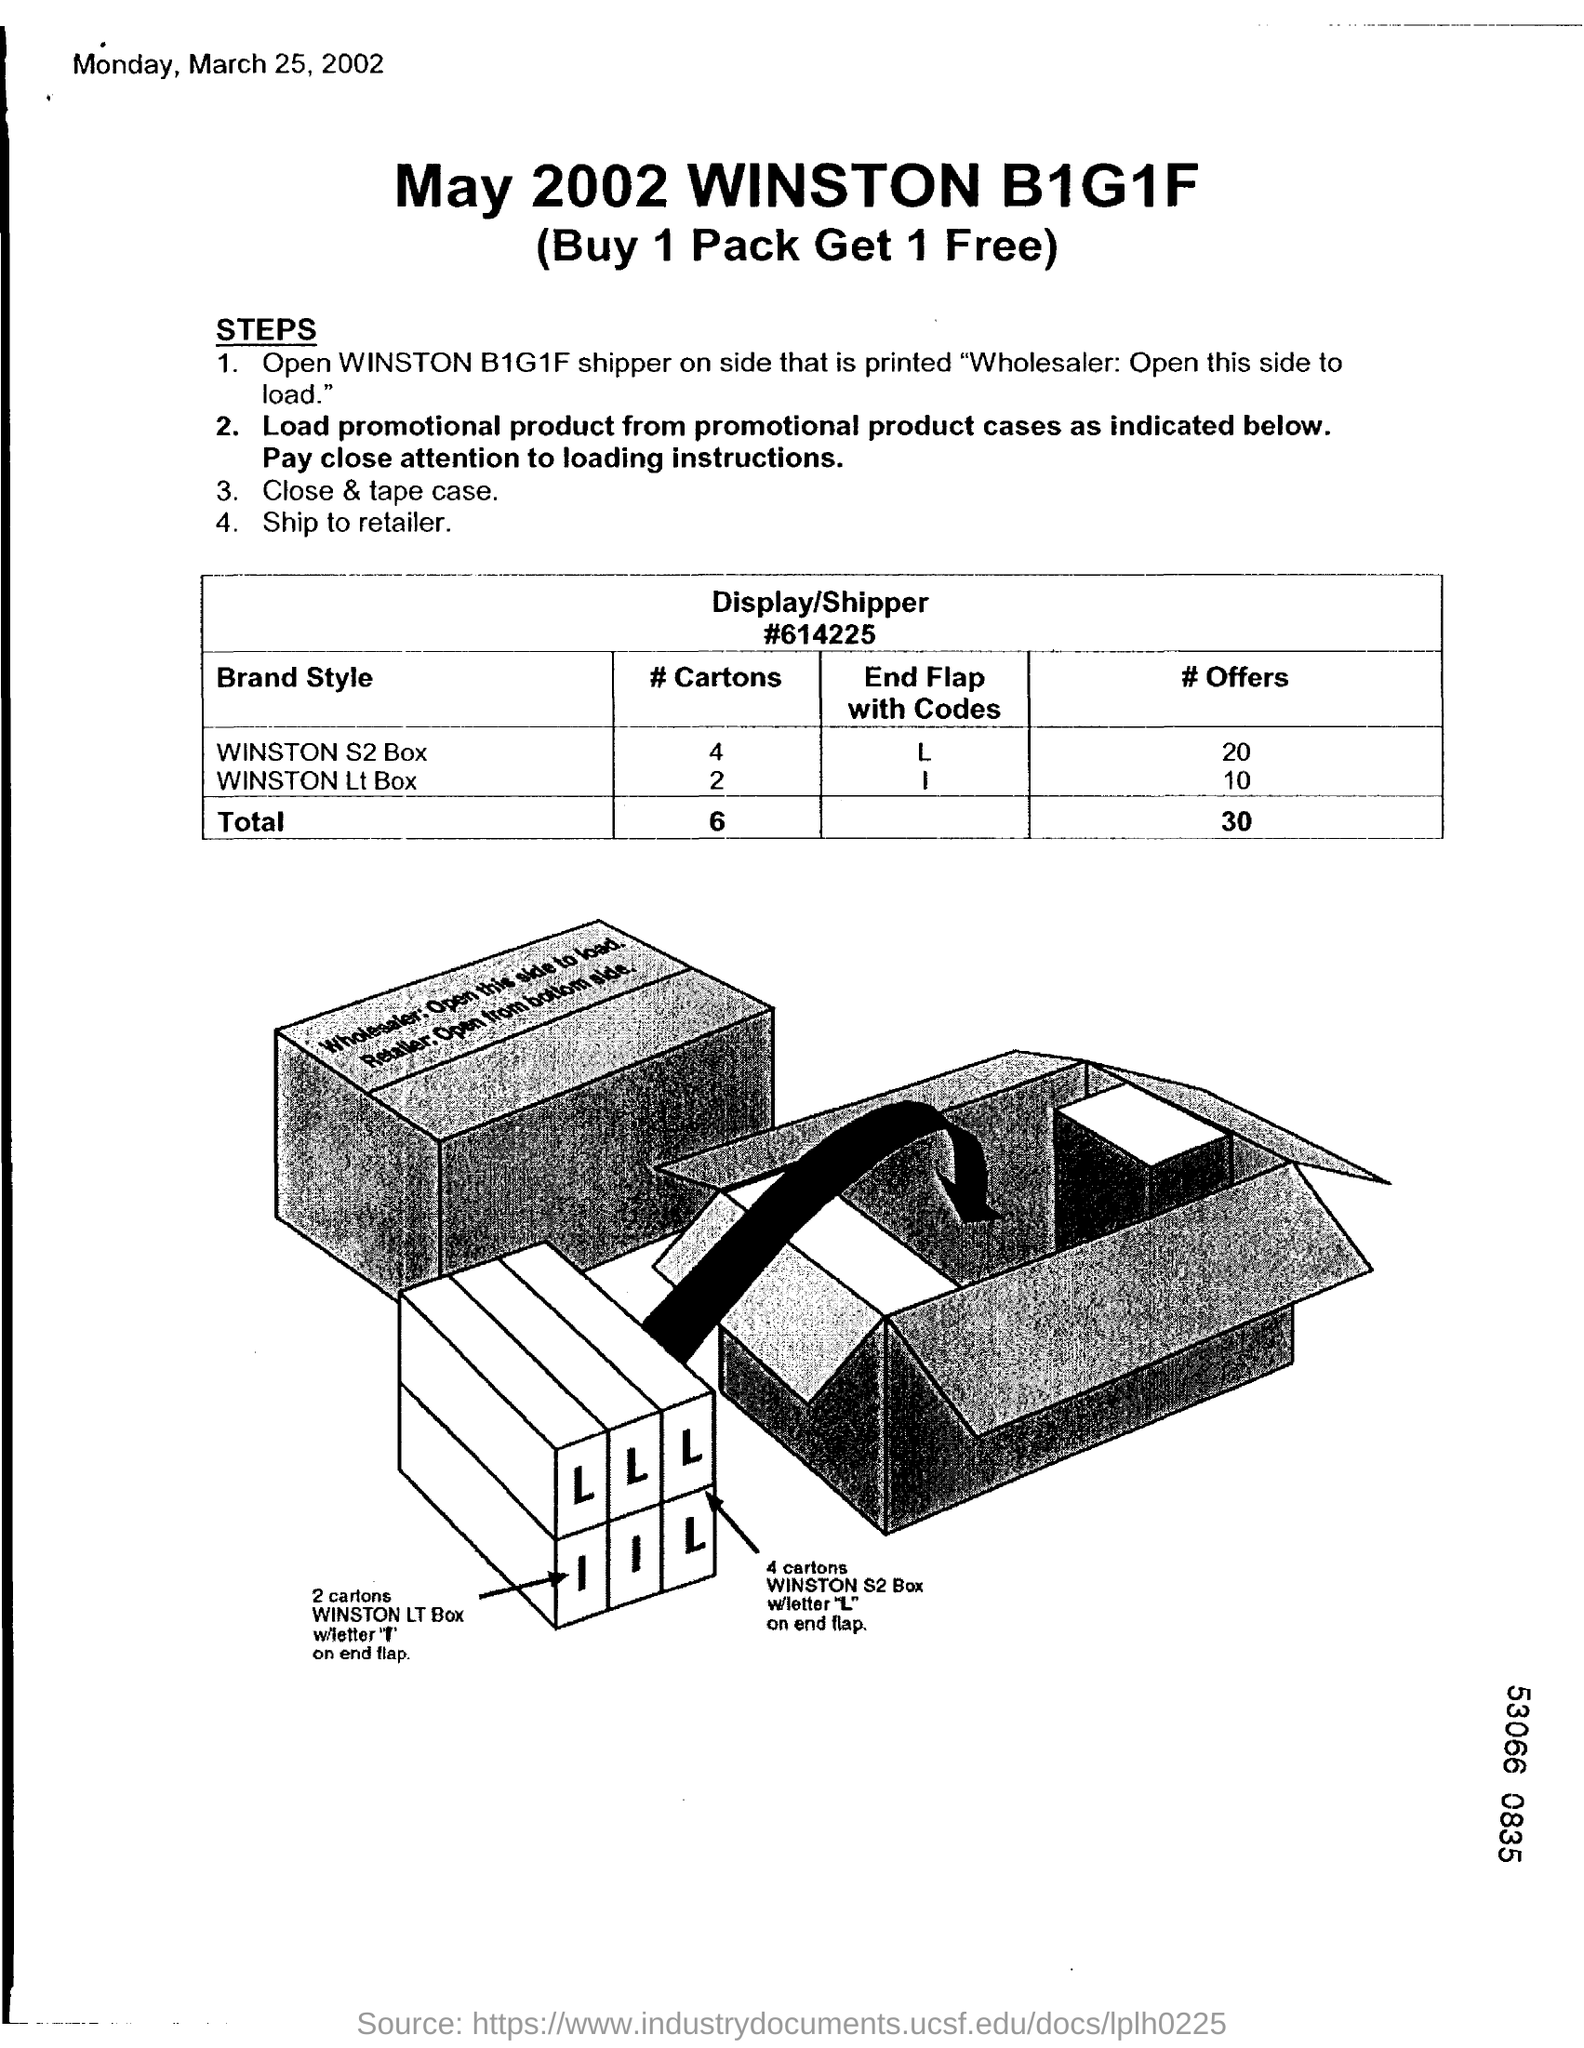Mention a couple of crucial points in this snapshot. The date indicated in the top left corner of the document is Monday, March 25, 2002. The document's title is May 2002 WINSTON B1G1F. 